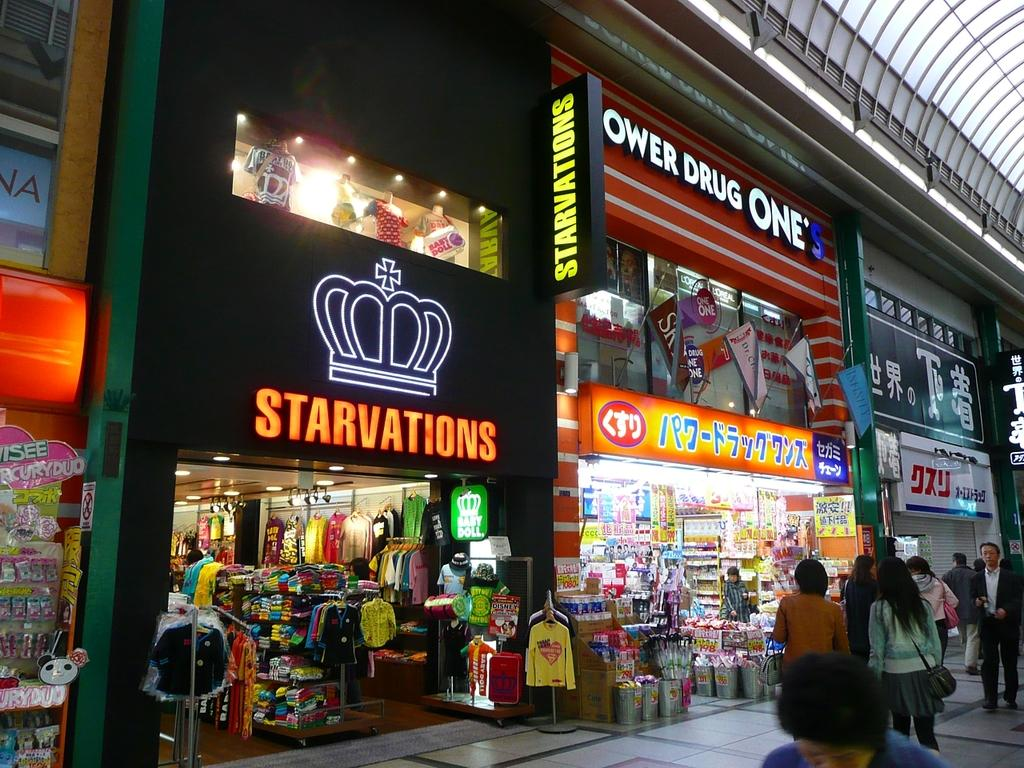<image>
Give a short and clear explanation of the subsequent image. A row of shops in Asia - the nearest of which is called: "Starvations". 